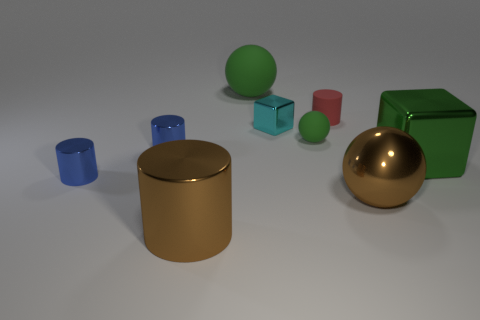Subtract all brown metallic balls. How many balls are left? 2 Subtract all gray cylinders. How many green balls are left? 2 Subtract all brown spheres. How many spheres are left? 2 Add 1 blocks. How many objects exist? 10 Subtract all red balls. Subtract all gray blocks. How many balls are left? 3 Add 5 big green rubber balls. How many big green rubber balls exist? 6 Subtract 1 green blocks. How many objects are left? 8 Subtract all balls. How many objects are left? 6 Subtract all green rubber balls. Subtract all big green blocks. How many objects are left? 6 Add 4 big green spheres. How many big green spheres are left? 5 